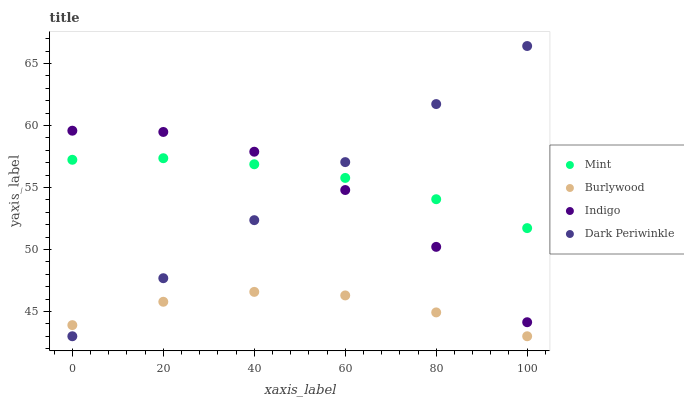Does Burlywood have the minimum area under the curve?
Answer yes or no. Yes. Does Mint have the maximum area under the curve?
Answer yes or no. Yes. Does Indigo have the minimum area under the curve?
Answer yes or no. No. Does Indigo have the maximum area under the curve?
Answer yes or no. No. Is Dark Periwinkle the smoothest?
Answer yes or no. Yes. Is Indigo the roughest?
Answer yes or no. Yes. Is Mint the smoothest?
Answer yes or no. No. Is Mint the roughest?
Answer yes or no. No. Does Burlywood have the lowest value?
Answer yes or no. Yes. Does Indigo have the lowest value?
Answer yes or no. No. Does Dark Periwinkle have the highest value?
Answer yes or no. Yes. Does Indigo have the highest value?
Answer yes or no. No. Is Burlywood less than Mint?
Answer yes or no. Yes. Is Mint greater than Burlywood?
Answer yes or no. Yes. Does Dark Periwinkle intersect Indigo?
Answer yes or no. Yes. Is Dark Periwinkle less than Indigo?
Answer yes or no. No. Is Dark Periwinkle greater than Indigo?
Answer yes or no. No. Does Burlywood intersect Mint?
Answer yes or no. No. 